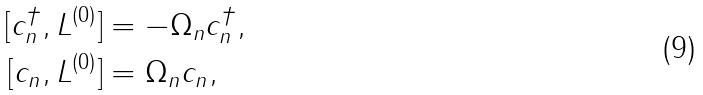Convert formula to latex. <formula><loc_0><loc_0><loc_500><loc_500>[ c ^ { \dag } _ { n } , L ^ { ( 0 ) } ] & = - \Omega _ { n } c ^ { \dag } _ { n } , \\ [ c _ { n } , L ^ { ( 0 ) } ] & = \Omega _ { n } c _ { n } ,</formula> 